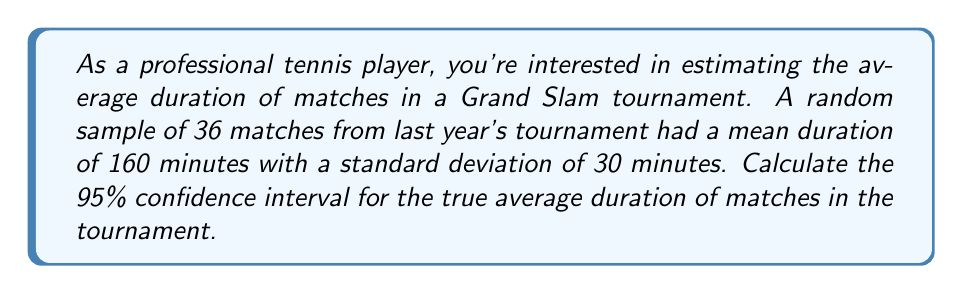Teach me how to tackle this problem. Let's approach this step-by-step:

1) We're given:
   - Sample size: $n = 36$
   - Sample mean: $\bar{x} = 160$ minutes
   - Sample standard deviation: $s = 30$ minutes
   - Confidence level: 95%

2) For a 95% confidence interval, we use a z-score of 1.96 (assuming normal distribution).

3) The formula for the confidence interval is:

   $$\bar{x} \pm z \cdot \frac{s}{\sqrt{n}}$$

4) Let's calculate the margin of error:

   $$\text{Margin of Error} = z \cdot \frac{s}{\sqrt{n}} = 1.96 \cdot \frac{30}{\sqrt{36}} = 1.96 \cdot \frac{30}{6} = 1.96 \cdot 5 = 9.8$$

5) Now we can calculate the confidence interval:

   Lower bound: $160 - 9.8 = 150.2$ minutes
   Upper bound: $160 + 9.8 = 169.8$ minutes

6) Therefore, we are 95% confident that the true average duration of matches in the Grand Slam tournament is between 150.2 and 169.8 minutes.
Answer: (150.2, 169.8) minutes 